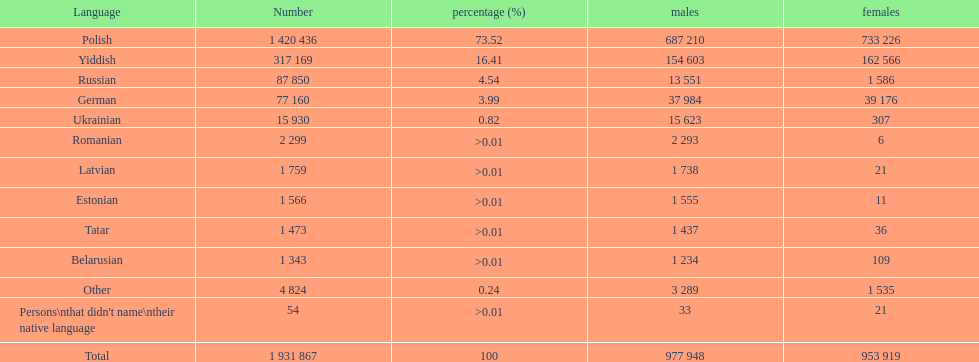What are the native languages in the warsaw governorate with more male speakers than female speakers? Russian, Ukrainian, Romanian, Latvian, Estonian, Tatar, Belarusian. For these languages, which have less than 500 males listed? Romanian, Latvian, Estonian, Tatar, Belarusian. Of the remaining languages, which have less than 20 females? Romanian, Estonian. Among these languages, which has the highest total number of speakers? Romanian. 